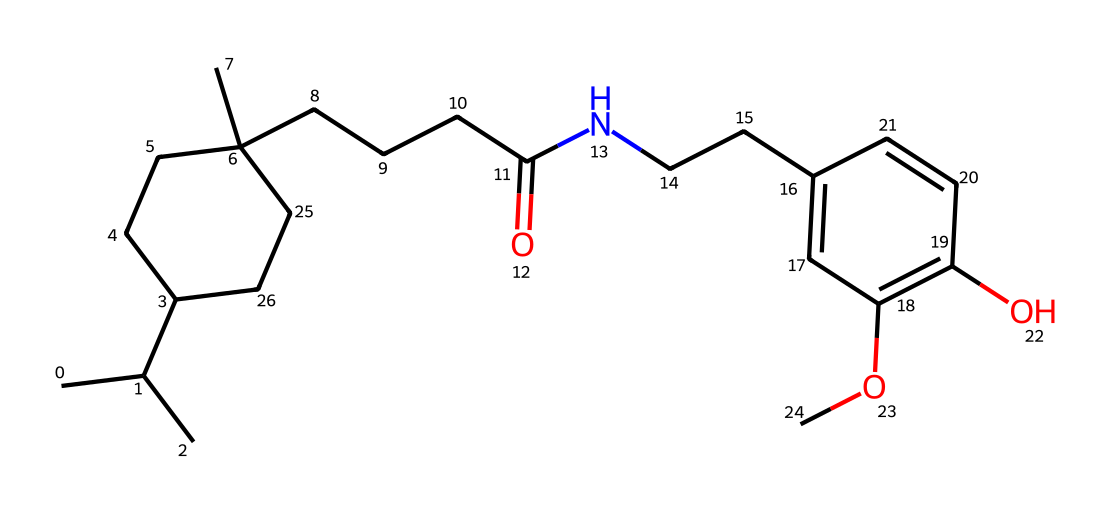What is the primary functional group present in the capsaicin structure? The chemical structure shows a carbonyl group (indicated by C(=O)), which is part of an amide functional group (linked to the nitrogen atom). This suggests that the primary functional group in capsaicin is an amide.
Answer: amide How many rings are present in the capsaicin structure? The structure contains one cycloalkane ring (C1CCC) as indicated by the numbers in the SMILES notation, suggesting a single ring structure.
Answer: one What type of aromatic system does the capsaicin molecule possess? The presence of a six-membered carbon ring with alternating double bonds (C=C) indicates that the capsaicin molecule has a phenolic structure, typical of aromatic compounds.
Answer: phenolic What is the molecular formula derived from the capsaicin structure? Analyzing the SMILES shows that the structure consists of several carbon (C), hydrogen (H), nitrogen (N), and oxygen (O) atoms. The molecular formula can be determined by counting: C18H27N1O3.
Answer: C18H27N1O3 How many oxygen atoms are present in the molecular structure? By examining the chemical structure, we can identify that there are three distinct oxygen atoms indicated in the molecular representation.
Answer: three What is the role of the alkene bonds in the capsaicin molecule? The alkene bonds (C=C) present in the aromatic system of capsaicin contribute to its stability and reactivity, playing a crucial role in the compound's chemical properties and interactions.
Answer: stability and reactivity Which atoms are responsible for the pungent flavor of capsaicin? The nitrogen atom in the amide functional group plays a critical role in the pungent taste associated with capsaicin, as this type of functional group is typically associated with strong flavors.
Answer: nitrogen 